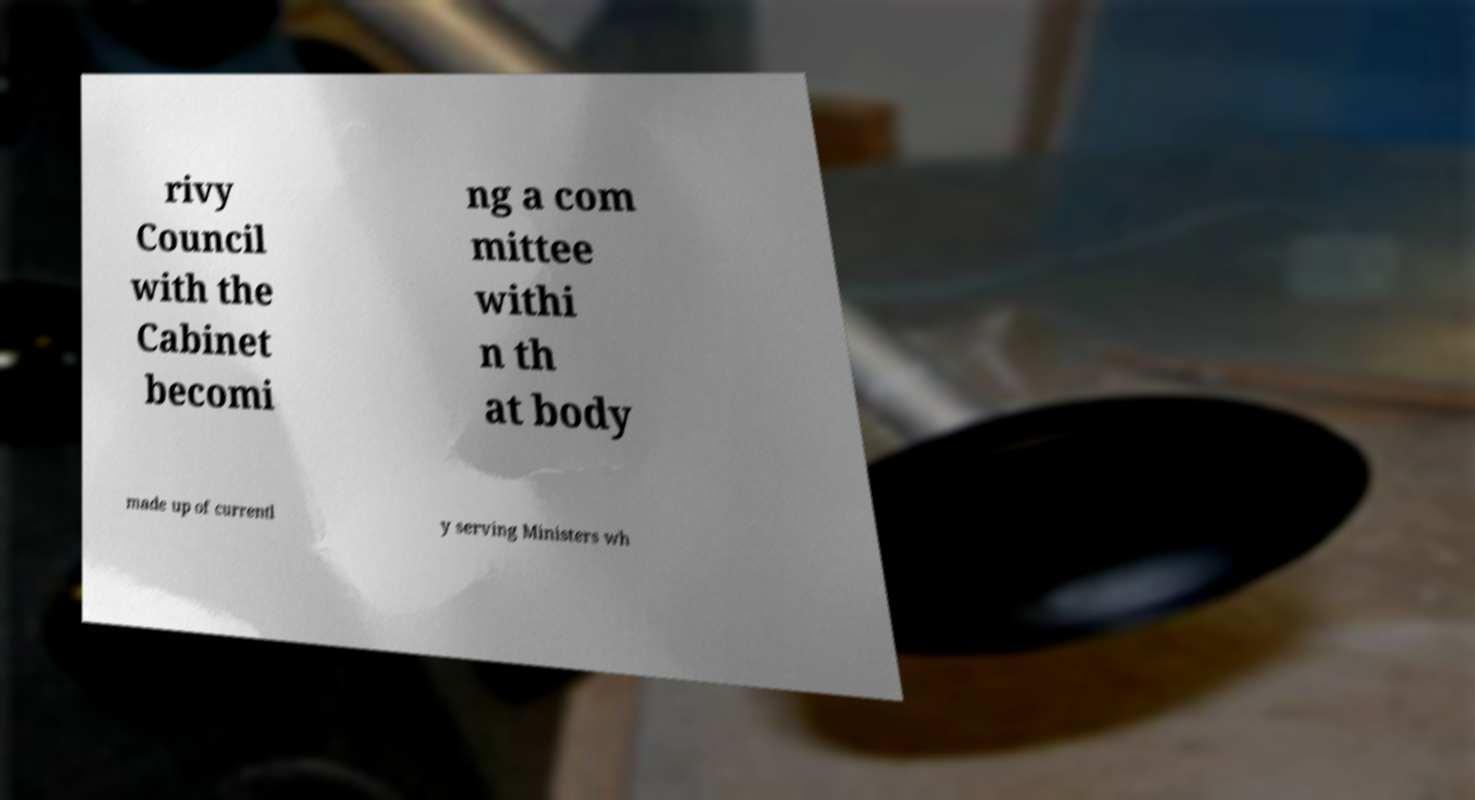Please read and relay the text visible in this image. What does it say? rivy Council with the Cabinet becomi ng a com mittee withi n th at body made up of currentl y serving Ministers wh 